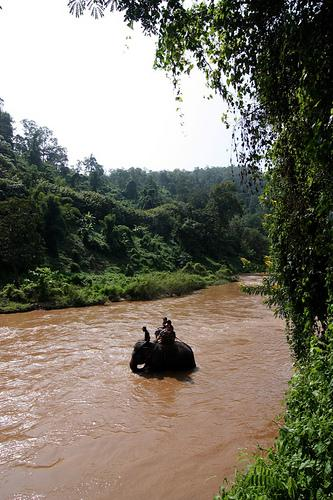Examine the complexity of the scene in the image based on the details provided. The scene is moderately complex with an elephant carrying people across a river, interaction between humans and animals in a jungle environment, muddy water, and jungle foliage along the river. How many elephant-related captions are present in the image information? 21 How many objects are mentioned within the captions related to the water/river? 4 (river with muddy water, muddy water, muddy river with people crossing, elephant in the river) What mode of transportation are people using in this picture? People are riding on the back of an elephant. Describe the emotions that the image may evoke in the viewer. The image can evoke a sense of adventure, curiosity, and excitement as people are traveling through a jungle on an elephant in a muddy river. Give a simple description of the setting in the image. An elephant is crossing a muddy river with people on its back, surrounded by foliage and jungle. What type of interaction is occurring between the people and the elephant in this image? People are riding on the back of the elephant, suggesting cooperation and mutual assistance between the people and the elephant. What kind of tour are the people participating in, based on the image? Traveling in the jungle on an elephant What can be deduced from the environment in the image? The image is set in a forest near a river, with foliage along the riverbank. Describe the environment around the river in the image. Foliage along the river with a muddy riverbank Identify the type of water body in the image. Muddy river Describe the interaction of the people and the elephant in the image. People are riding on the elephant, crossing a river. Describe an object in the scene, based on its coordinates. Elephant in the water Mention an event that can be inferred from the image. People and elephant crossing a muddy river Which of the following captions correctly describes the scene: a) people riding on a giraffe, b) elephant in the river, c) lions playing in the water? b) elephant in the river Choose the correct caption for the image: a) Cat in the grass, b) Elephant walking in a park, c) People riding an elephant crossing a river c) People riding an elephant crossing a river What animal can be seen in the image? Elephant What does the image depict about the elephant's activity? The elephant is crossing the river carrying people. Based on the image, where are the people positioned on the elephant? On the back of the elephant What is the primary activity that the people and elephant are engaged in? Crossing the river How would you describe the overall mood of the scene in the image? Adventurous, as people travel in the jungle on an elephant Is anyone riding on the elephant in the image? Yes, people are riding on the elephant. What do the people in the image appear to be doing? Crossing a muddy river on the back of an elephant Based on the image content, what type of tour are the people experiencing? A tour of the forest riding an elephant In the image, what can be said about the river's appearance? The river has muddy water. Does the elephant appear to be carrying the people or the people are simply standing beside it? The elephant appears to be carrying the people. 